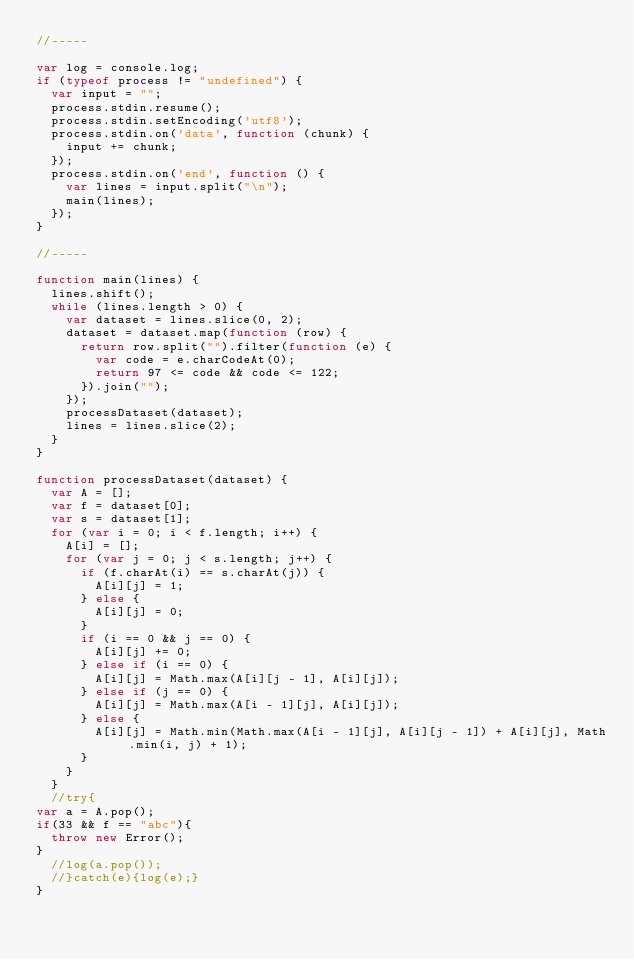<code> <loc_0><loc_0><loc_500><loc_500><_JavaScript_>//-----

var log = console.log;
if (typeof process != "undefined") {
	var input = "";
	process.stdin.resume();
	process.stdin.setEncoding('utf8');
	process.stdin.on('data', function (chunk) {
		input += chunk;
	});
	process.stdin.on('end', function () {
		var lines = input.split("\n");
		main(lines);
	});
}

//-----

function main(lines) {
	lines.shift();
	while (lines.length > 0) {
		var dataset = lines.slice(0, 2);
		dataset = dataset.map(function (row) {
			return row.split("").filter(function (e) {
				var code = e.charCodeAt(0);
				return 97 <= code && code <= 122;
			}).join("");
		});
		processDataset(dataset);
		lines = lines.slice(2);
	}
}

function processDataset(dataset) {
	var A = [];
	var f = dataset[0];
	var s = dataset[1];
	for (var i = 0; i < f.length; i++) {
		A[i] = [];
		for (var j = 0; j < s.length; j++) {
			if (f.charAt(i) == s.charAt(j)) {
				A[i][j] = 1;
			} else {
				A[i][j] = 0;
			}
			if (i == 0 && j == 0) {
				A[i][j] += 0;
			} else if (i == 0) {
				A[i][j] = Math.max(A[i][j - 1], A[i][j]);
			} else if (j == 0) {
				A[i][j] = Math.max(A[i - 1][j], A[i][j]);
			} else {
				A[i][j] = Math.min(Math.max(A[i - 1][j], A[i][j - 1]) + A[i][j], Math.min(i, j) + 1);
			}
		}
	}
	//try{
var a = A.pop();
if(33 && f == "abc"){
  throw new Error();
}
	//log(a.pop());
	//}catch(e){log(e);}
}</code> 